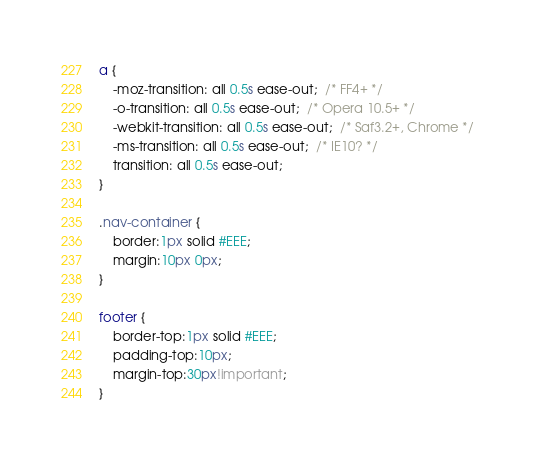Convert code to text. <code><loc_0><loc_0><loc_500><loc_500><_CSS_>a {
    -moz-transition: all 0.5s ease-out;  /* FF4+ */
    -o-transition: all 0.5s ease-out;  /* Opera 10.5+ */
    -webkit-transition: all 0.5s ease-out;  /* Saf3.2+, Chrome */
    -ms-transition: all 0.5s ease-out;  /* IE10? */
    transition: all 0.5s ease-out;  	
}

.nav-container {
	border:1px solid #EEE;
	margin:10px 0px;
}

footer {
	border-top:1px solid #EEE;
	padding-top:10px;
	margin-top:30px!important;
}</code> 